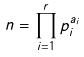Convert formula to latex. <formula><loc_0><loc_0><loc_500><loc_500>n = \prod _ { i = 1 } ^ { r } p _ { i } ^ { a _ { i } }</formula> 